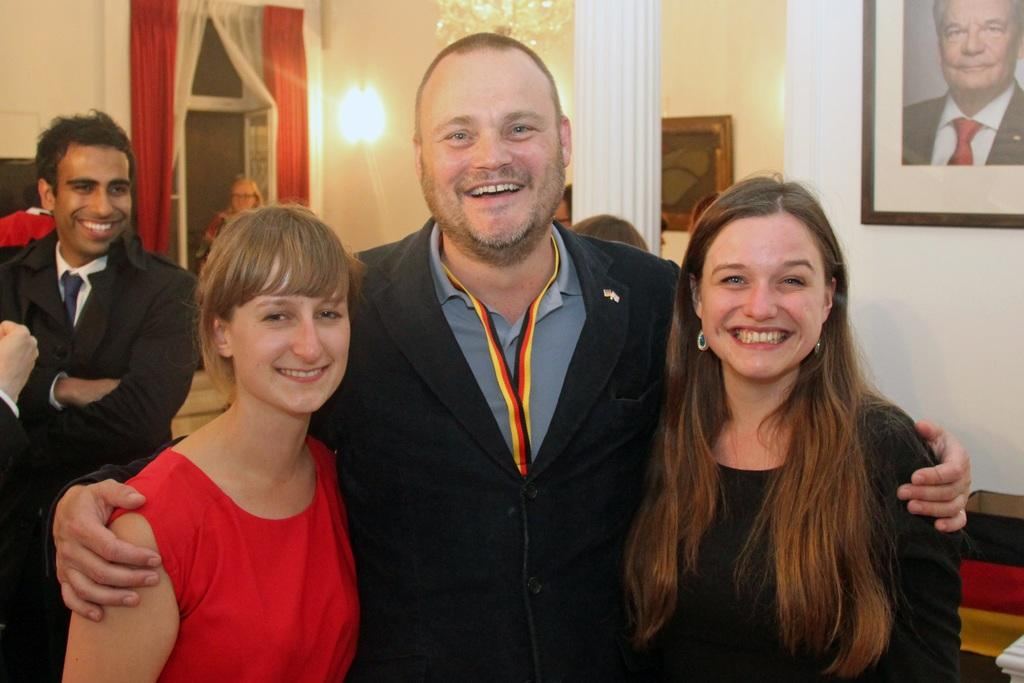What can be seen in the room in the image? There are people standing in the room. Are there any architectural features in the room? Yes, there is a pillar in the room. What type of window treatment is present in the room? There are curtains on the window. What is the source of light in the room? There is a light in the room. What decorative elements can be seen on the wall in the background? There are picture frames on the wall in the background. What type of hair can be seen on the police officer in the image? There are no police officers or any reference to hair in the image. What type of coastline can be seen through the window in the image? There is no coastline visible in the image, as it features a room with people, a pillar, curtains, a light, and picture frames on the wall. 